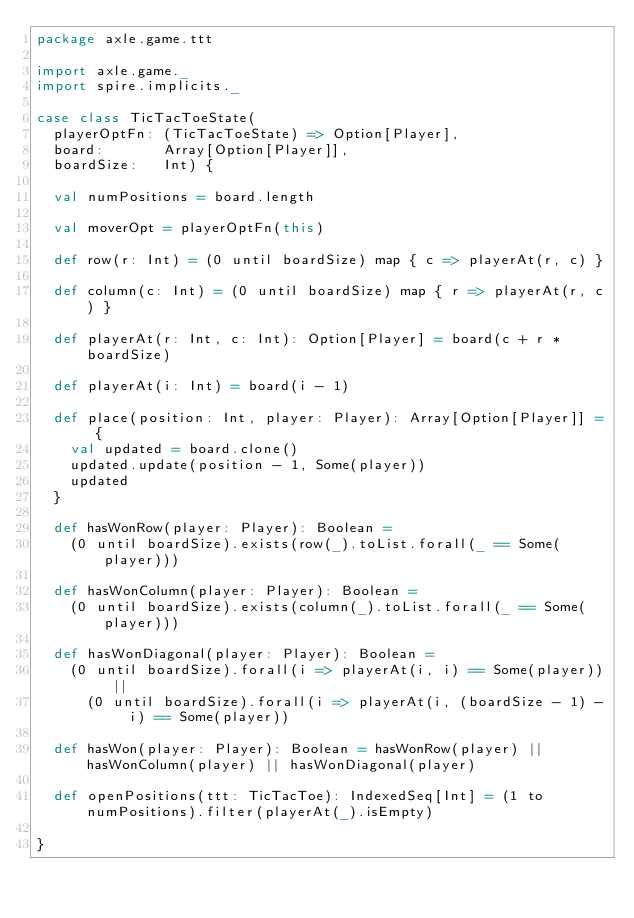<code> <loc_0><loc_0><loc_500><loc_500><_Scala_>package axle.game.ttt

import axle.game._
import spire.implicits._

case class TicTacToeState(
  playerOptFn: (TicTacToeState) => Option[Player],
  board:       Array[Option[Player]],
  boardSize:   Int) {

  val numPositions = board.length

  val moverOpt = playerOptFn(this)

  def row(r: Int) = (0 until boardSize) map { c => playerAt(r, c) }

  def column(c: Int) = (0 until boardSize) map { r => playerAt(r, c) }

  def playerAt(r: Int, c: Int): Option[Player] = board(c + r * boardSize)

  def playerAt(i: Int) = board(i - 1)

  def place(position: Int, player: Player): Array[Option[Player]] = {
    val updated = board.clone()
    updated.update(position - 1, Some(player))
    updated
  }

  def hasWonRow(player: Player): Boolean =
    (0 until boardSize).exists(row(_).toList.forall(_ == Some(player)))

  def hasWonColumn(player: Player): Boolean =
    (0 until boardSize).exists(column(_).toList.forall(_ == Some(player)))

  def hasWonDiagonal(player: Player): Boolean =
    (0 until boardSize).forall(i => playerAt(i, i) == Some(player)) ||
      (0 until boardSize).forall(i => playerAt(i, (boardSize - 1) - i) == Some(player))

  def hasWon(player: Player): Boolean = hasWonRow(player) || hasWonColumn(player) || hasWonDiagonal(player)

  def openPositions(ttt: TicTacToe): IndexedSeq[Int] = (1 to numPositions).filter(playerAt(_).isEmpty)

}
</code> 